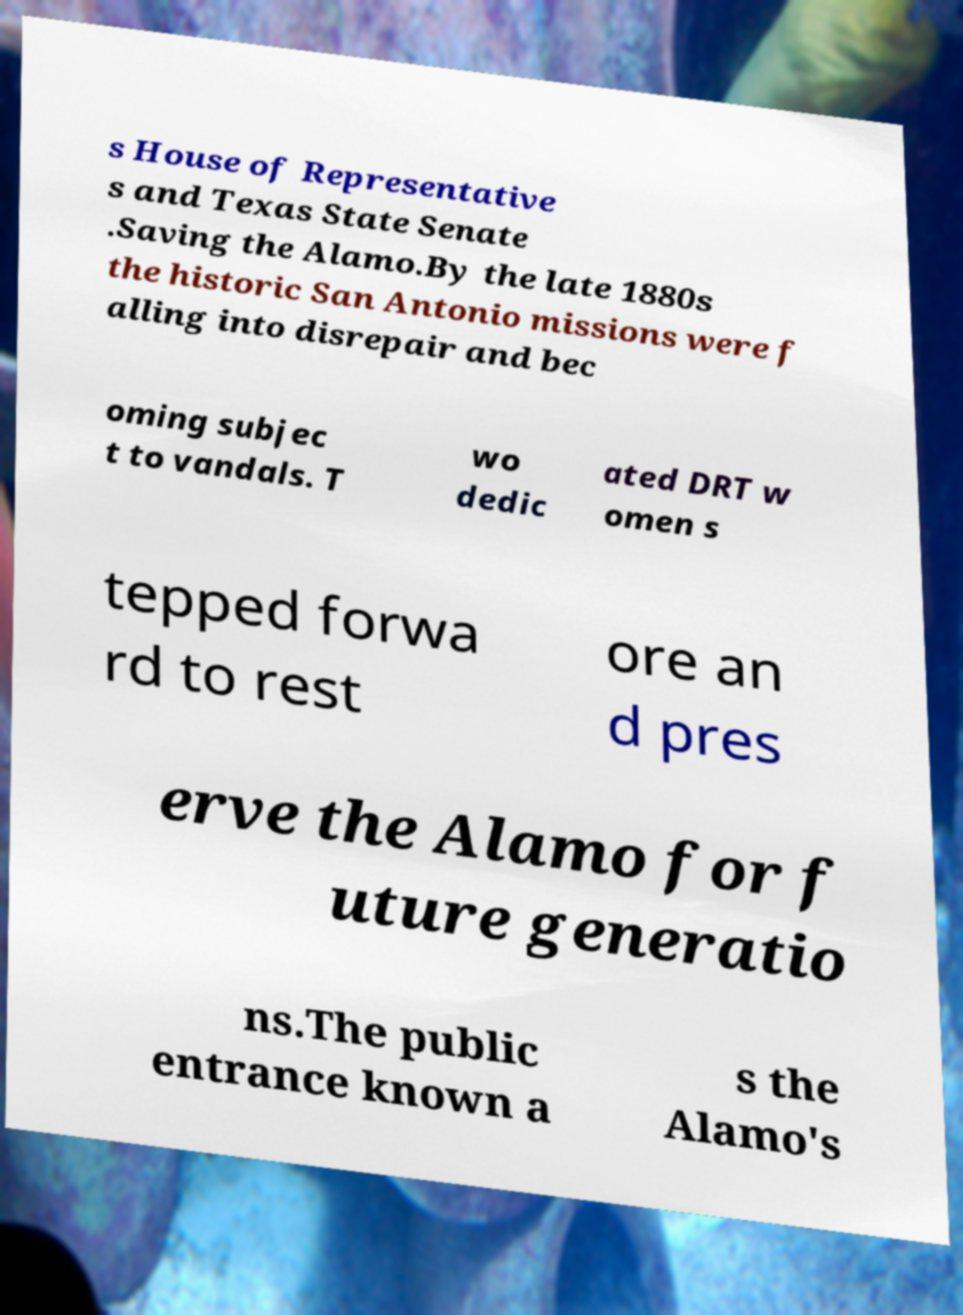What messages or text are displayed in this image? I need them in a readable, typed format. s House of Representative s and Texas State Senate .Saving the Alamo.By the late 1880s the historic San Antonio missions were f alling into disrepair and bec oming subjec t to vandals. T wo dedic ated DRT w omen s tepped forwa rd to rest ore an d pres erve the Alamo for f uture generatio ns.The public entrance known a s the Alamo's 